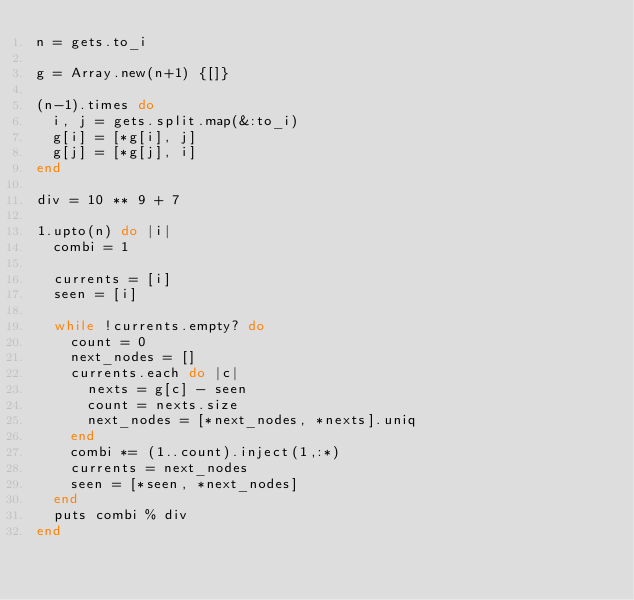<code> <loc_0><loc_0><loc_500><loc_500><_Ruby_>n = gets.to_i

g = Array.new(n+1) {[]}

(n-1).times do
  i, j = gets.split.map(&:to_i)
  g[i] = [*g[i], j]
  g[j] = [*g[j], i]
end

div = 10 ** 9 + 7

1.upto(n) do |i|
  combi = 1

  currents = [i]
  seen = [i]

  while !currents.empty? do
    count = 0
    next_nodes = []
    currents.each do |c|
      nexts = g[c] - seen
      count = nexts.size
      next_nodes = [*next_nodes, *nexts].uniq
    end
    combi *= (1..count).inject(1,:*)
    currents = next_nodes
    seen = [*seen, *next_nodes]
  end
  puts combi % div
end
  
</code> 